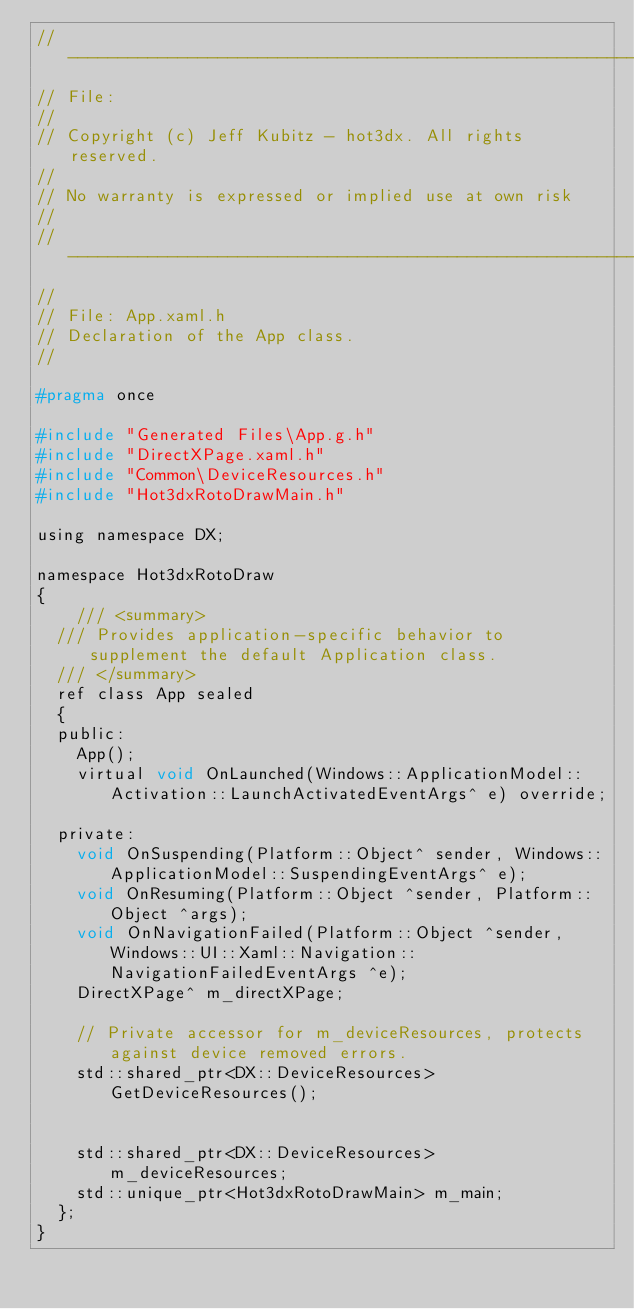<code> <loc_0><loc_0><loc_500><loc_500><_C_>//--------------------------------------------------------------------------------------
// File: 
//
// Copyright (c) Jeff Kubitz - hot3dx. All rights reserved.
// 
// No warranty is expressed or implied use at own risk
//
//--------------------------------------------------------------------------------------
//
// File: App.xaml.h
// Declaration of the App class.
//

#pragma once

#include "Generated Files\App.g.h"
#include "DirectXPage.xaml.h"
#include "Common\DeviceResources.h"
#include "Hot3dxRotoDrawMain.h"

using namespace DX;

namespace Hot3dxRotoDraw
{
		/// <summary>
	/// Provides application-specific behavior to supplement the default Application class.
	/// </summary>
	ref class App sealed
	{
	public:
		App();
		virtual void OnLaunched(Windows::ApplicationModel::Activation::LaunchActivatedEventArgs^ e) override;
		
	private:
		void OnSuspending(Platform::Object^ sender, Windows::ApplicationModel::SuspendingEventArgs^ e);
		void OnResuming(Platform::Object ^sender, Platform::Object ^args);
		void OnNavigationFailed(Platform::Object ^sender, Windows::UI::Xaml::Navigation::NavigationFailedEventArgs ^e);
		DirectXPage^ m_directXPage;

		// Private accessor for m_deviceResources, protects against device removed errors.
		std::shared_ptr<DX::DeviceResources> GetDeviceResources();


		std::shared_ptr<DX::DeviceResources> m_deviceResources;
		std::unique_ptr<Hot3dxRotoDrawMain> m_main;
	};
}</code> 